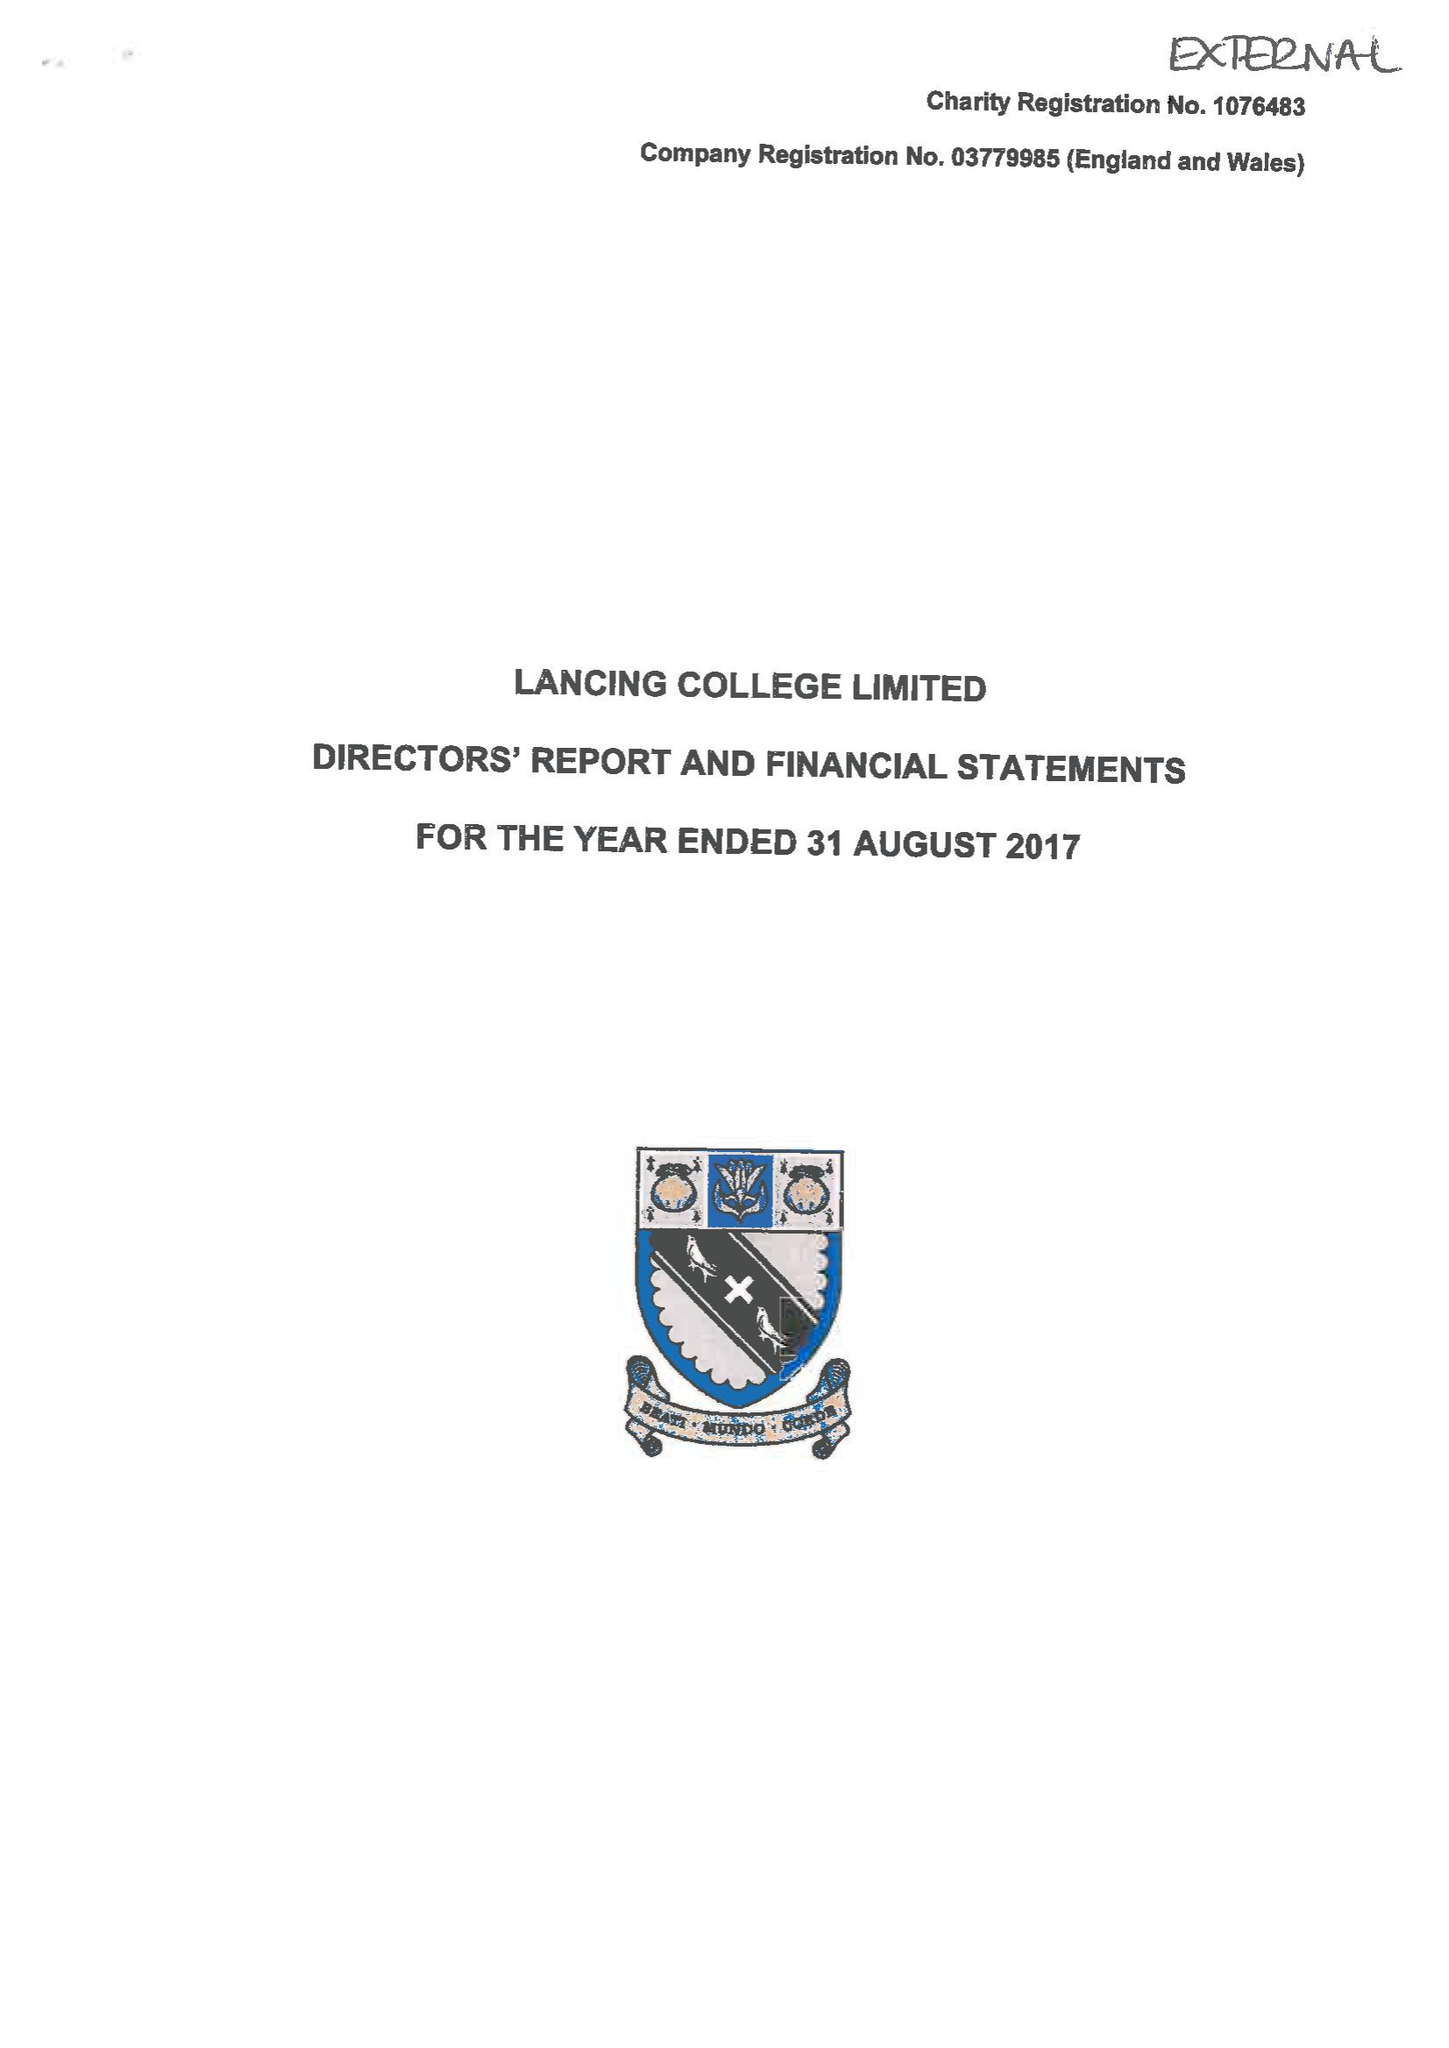What is the value for the address__street_line?
Answer the question using a single word or phrase. None 